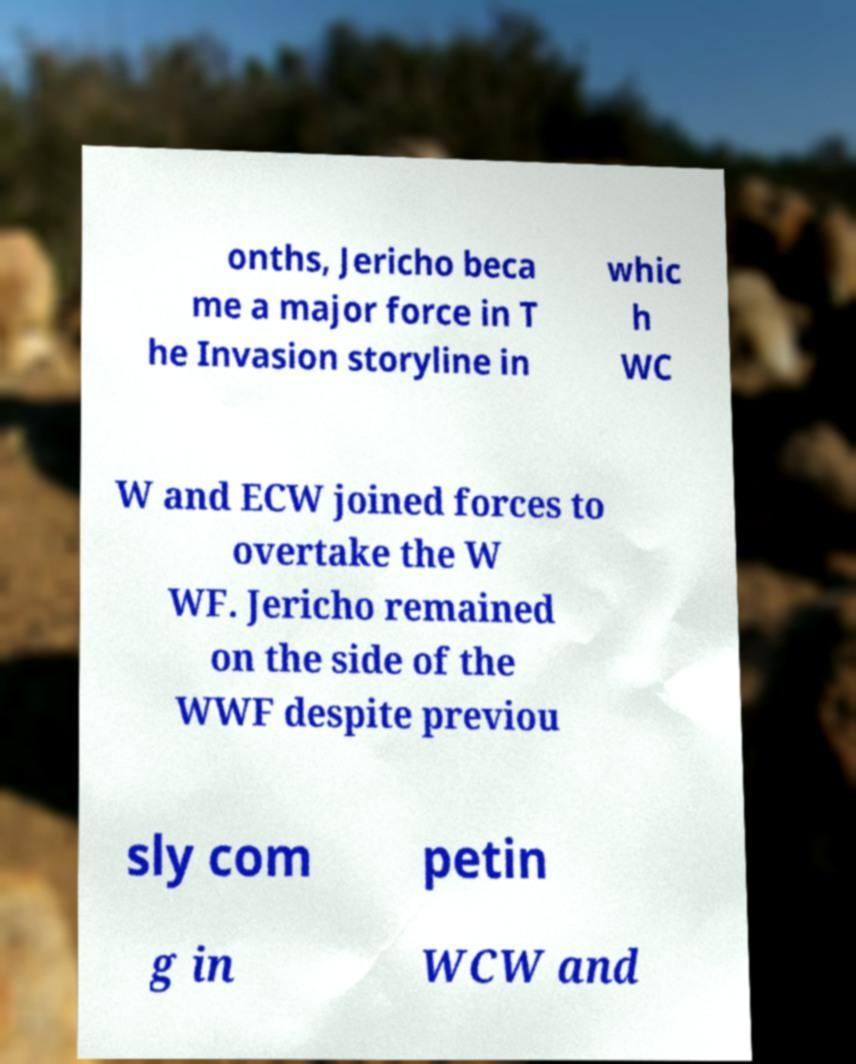Could you assist in decoding the text presented in this image and type it out clearly? onths, Jericho beca me a major force in T he Invasion storyline in whic h WC W and ECW joined forces to overtake the W WF. Jericho remained on the side of the WWF despite previou sly com petin g in WCW and 